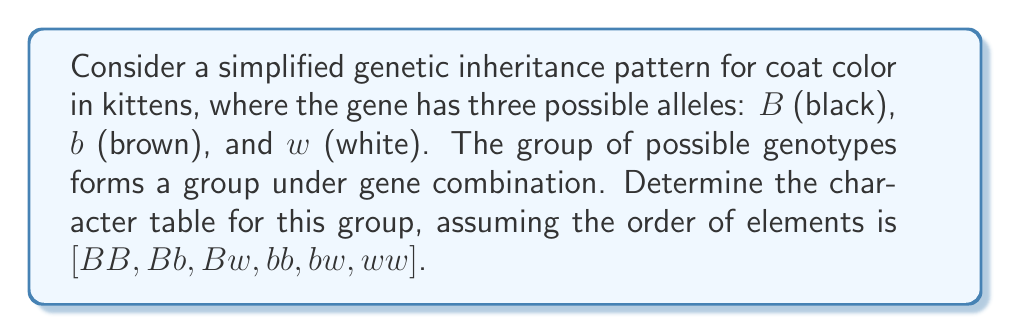Can you answer this question? To determine the character table for this group, we'll follow these steps:

1) First, identify the group structure:
   This group is isomorphic to $S_3$, the symmetric group on 3 elements.

2) The conjugacy classes of $S_3$ are:
   $\{e\} = \{BB\}$
   $\{(12), (13), (23)\} = \{Bb, Bw, bw\}$
   $\{(123), (132)\} = \{bb, ww\}$

3) $S_3$ has 3 irreducible representations:
   - The trivial representation (1-dimensional)
   - The sign representation (1-dimensional)
   - A 2-dimensional representation

4) For the trivial representation $\chi_1$:
   $\chi_1(g) = 1$ for all $g$

5) For the sign representation $\chi_2$:
   $\chi_2(e) = 1$
   $\chi_2((12)) = -1$
   $\chi_2((123)) = 1$

6) For the 2-dimensional representation $\chi_3$:
   $\chi_3(e) = 2$
   $\chi_3((12)) = 0$
   $\chi_3((123)) = -1$

7) Construct the character table:

   $$
   \begin{array}{c|ccc}
    & \{BB\} & \{Bb, Bw, bw\} & \{bb, ww\} \\
   \hline
   \chi_1 & 1 & 1 & 1 \\
   \chi_2 & 1 & -1 & 1 \\
   \chi_3 & 2 & 0 & -1
   \end{array}
   $$

This character table represents the irreducible characters of the group, showing how each representation behaves on each conjugacy class.
Answer: $$
\begin{array}{c|ccc}
 & \{BB\} & \{Bb, Bw, bw\} & \{bb, ww\} \\
\hline
\chi_1 & 1 & 1 & 1 \\
\chi_2 & 1 & -1 & 1 \\
\chi_3 & 2 & 0 & -1
\end{array}
$$ 